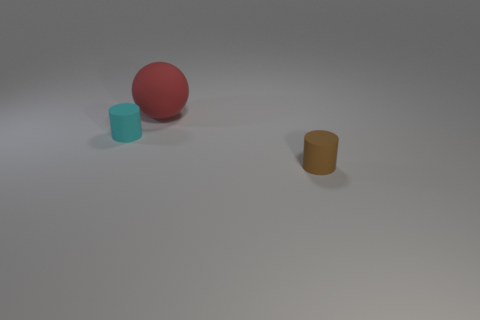Are any small blue metallic blocks visible? no 